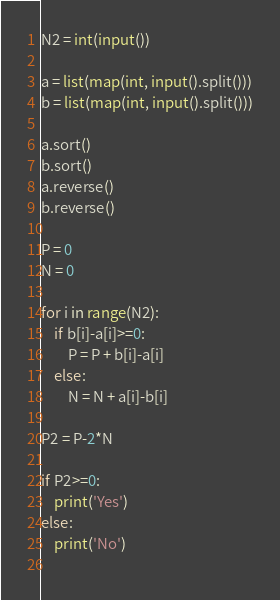<code> <loc_0><loc_0><loc_500><loc_500><_Python_>N2 = int(input())

a = list(map(int, input().split()))
b = list(map(int, input().split()))

a.sort()
b.sort()
a.reverse()
b.reverse()

P = 0
N = 0

for i in range(N2):
    if b[i]-a[i]>=0:
        P = P + b[i]-a[i]
    else:
        N = N + a[i]-b[i]
       
P2 = P-2*N
        
if P2>=0:
    print('Yes')
else:
    print('No')
        </code> 